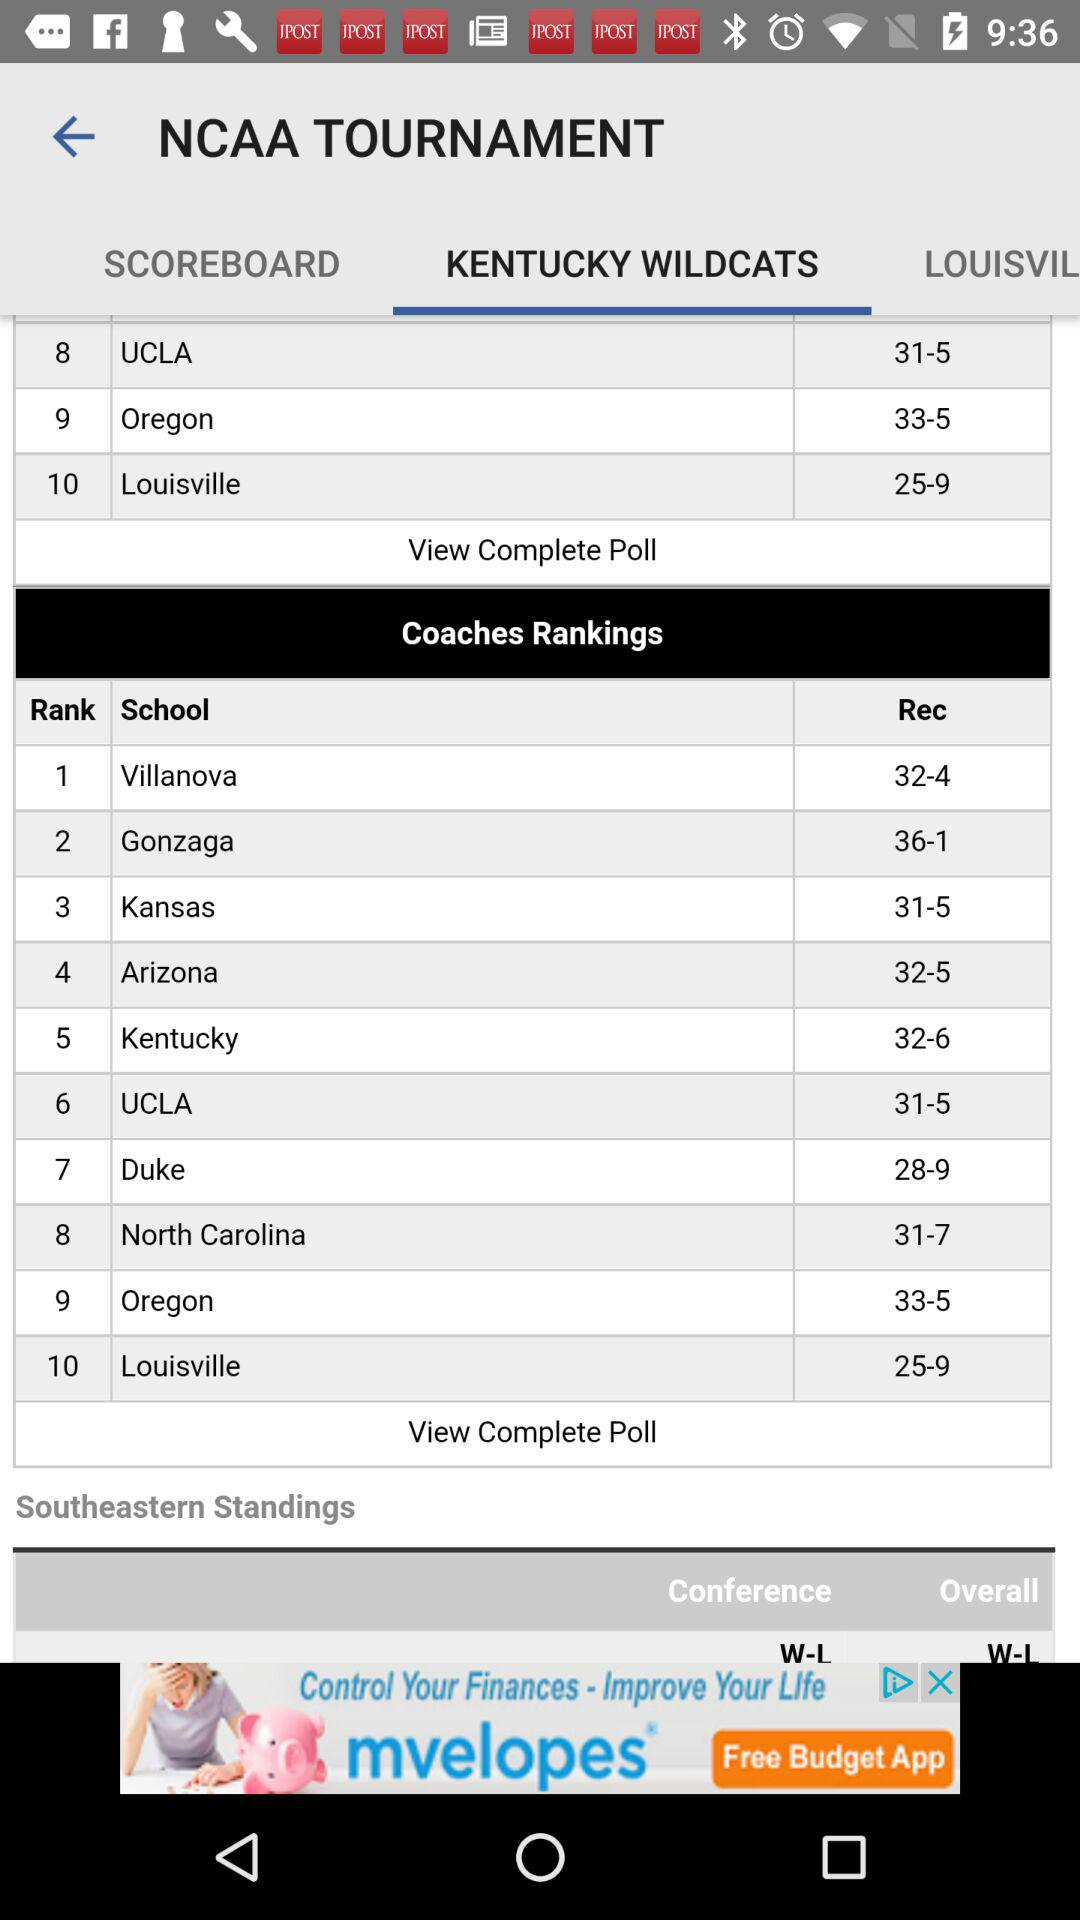Which tab is selected? The selected tab is "KENTUCKY WILDCATS". 